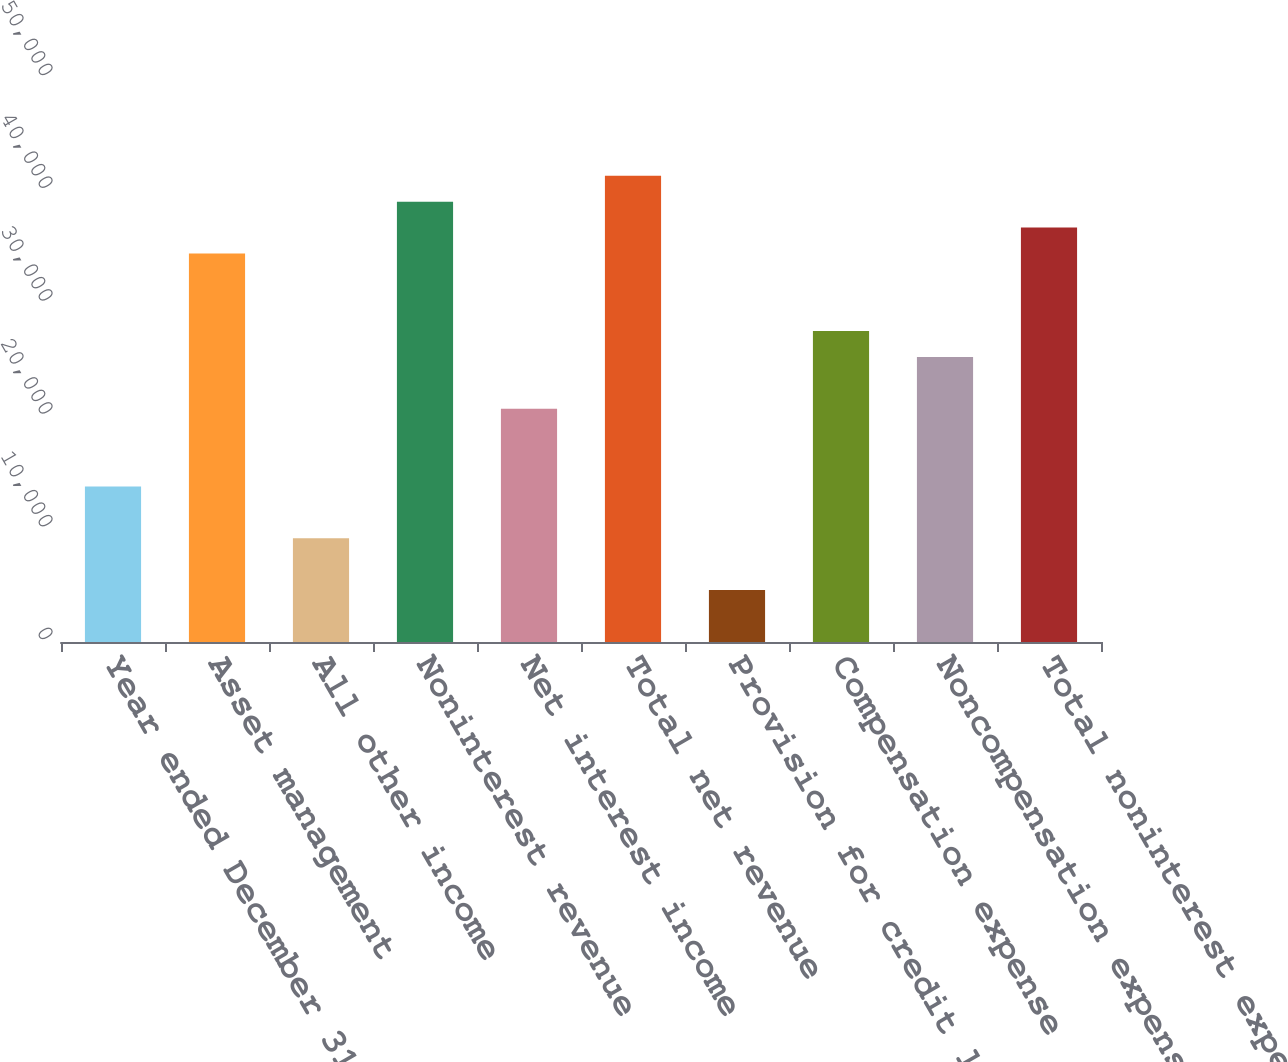Convert chart. <chart><loc_0><loc_0><loc_500><loc_500><bar_chart><fcel>Year ended December 31 (in<fcel>Asset management<fcel>All other income<fcel>Noninterest revenue<fcel>Net interest income<fcel>Total net revenue<fcel>Provision for credit losses<fcel>Compensation expense<fcel>Noncompensation expense<fcel>Total noninterest expense<nl><fcel>13795<fcel>34450<fcel>9205<fcel>39040<fcel>20680<fcel>41335<fcel>4615<fcel>27565<fcel>25270<fcel>36745<nl></chart> 